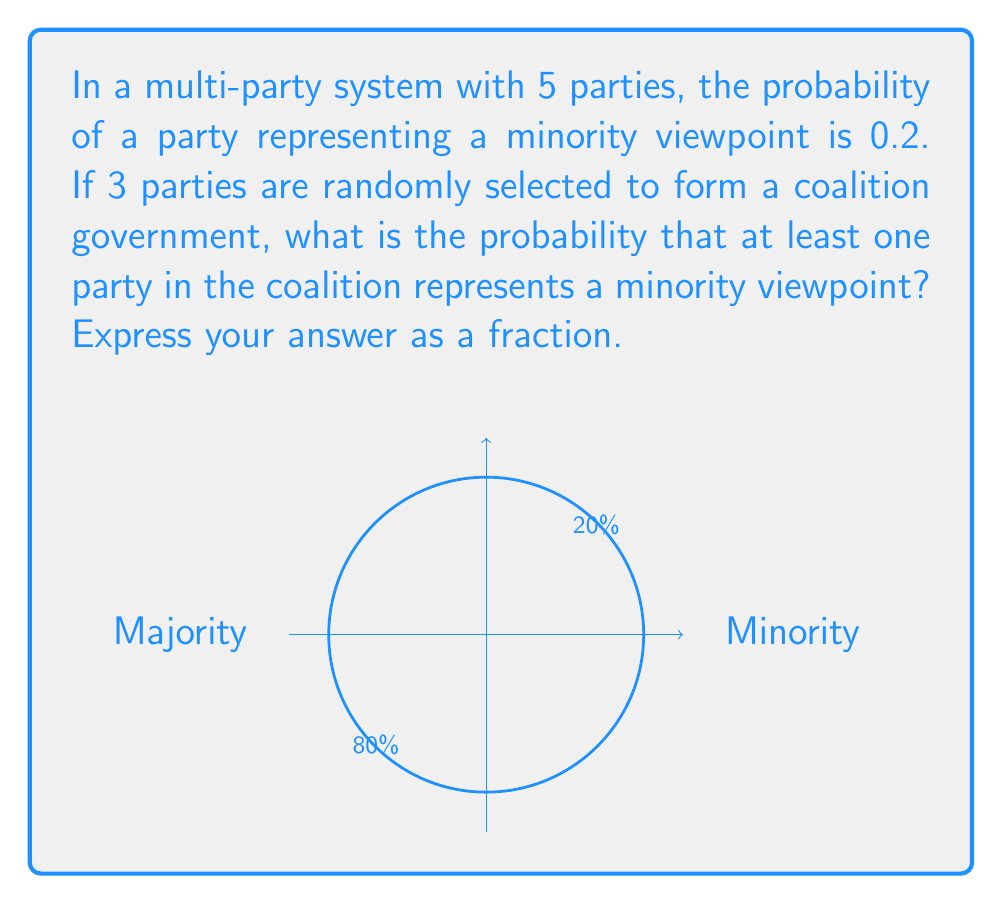Show me your answer to this math problem. Let's approach this step-by-step:

1) First, let's consider the probability of a party NOT representing a minority viewpoint:
   $P(\text{not minority}) = 1 - 0.2 = 0.8$

2) Now, for the coalition to NOT include any minority viewpoint, all 3 selected parties must not represent a minority viewpoint. The probability of this is:
   $P(\text{no minority in coalition}) = 0.8^3 = 0.512$

3) Therefore, the probability of at least one party in the coalition representing a minority viewpoint is the complement of this probability:
   $P(\text{at least one minority}) = 1 - P(\text{no minority in coalition})$
   $= 1 - 0.512 = 0.488$

4) To express this as a fraction, we can convert 0.488 to:
   $\frac{488}{1000} = \frac{122}{250}$

This fraction can't be reduced further, as 122 and 250 have no common factors other than 1.
Answer: $\frac{122}{250}$ 